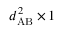Convert formula to latex. <formula><loc_0><loc_0><loc_500><loc_500>d _ { A B } ^ { 2 } \times 1</formula> 